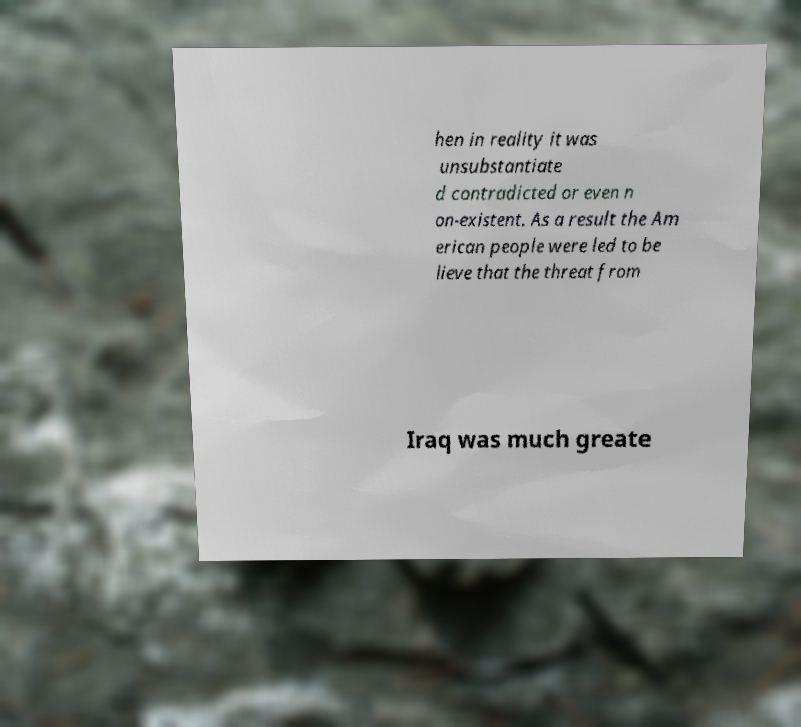I need the written content from this picture converted into text. Can you do that? hen in reality it was unsubstantiate d contradicted or even n on-existent. As a result the Am erican people were led to be lieve that the threat from Iraq was much greate 